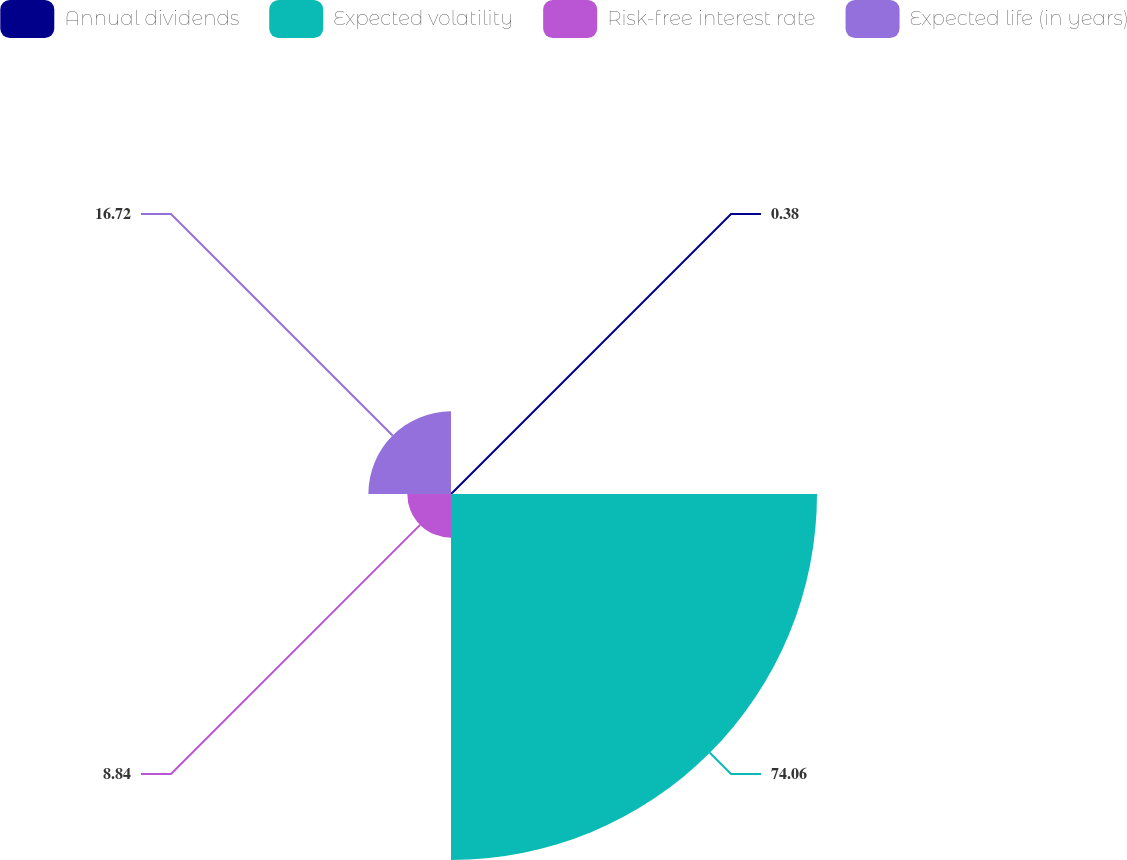Convert chart. <chart><loc_0><loc_0><loc_500><loc_500><pie_chart><fcel>Annual dividends<fcel>Expected volatility<fcel>Risk-free interest rate<fcel>Expected life (in years)<nl><fcel>0.38%<fcel>74.06%<fcel>8.84%<fcel>16.72%<nl></chart> 